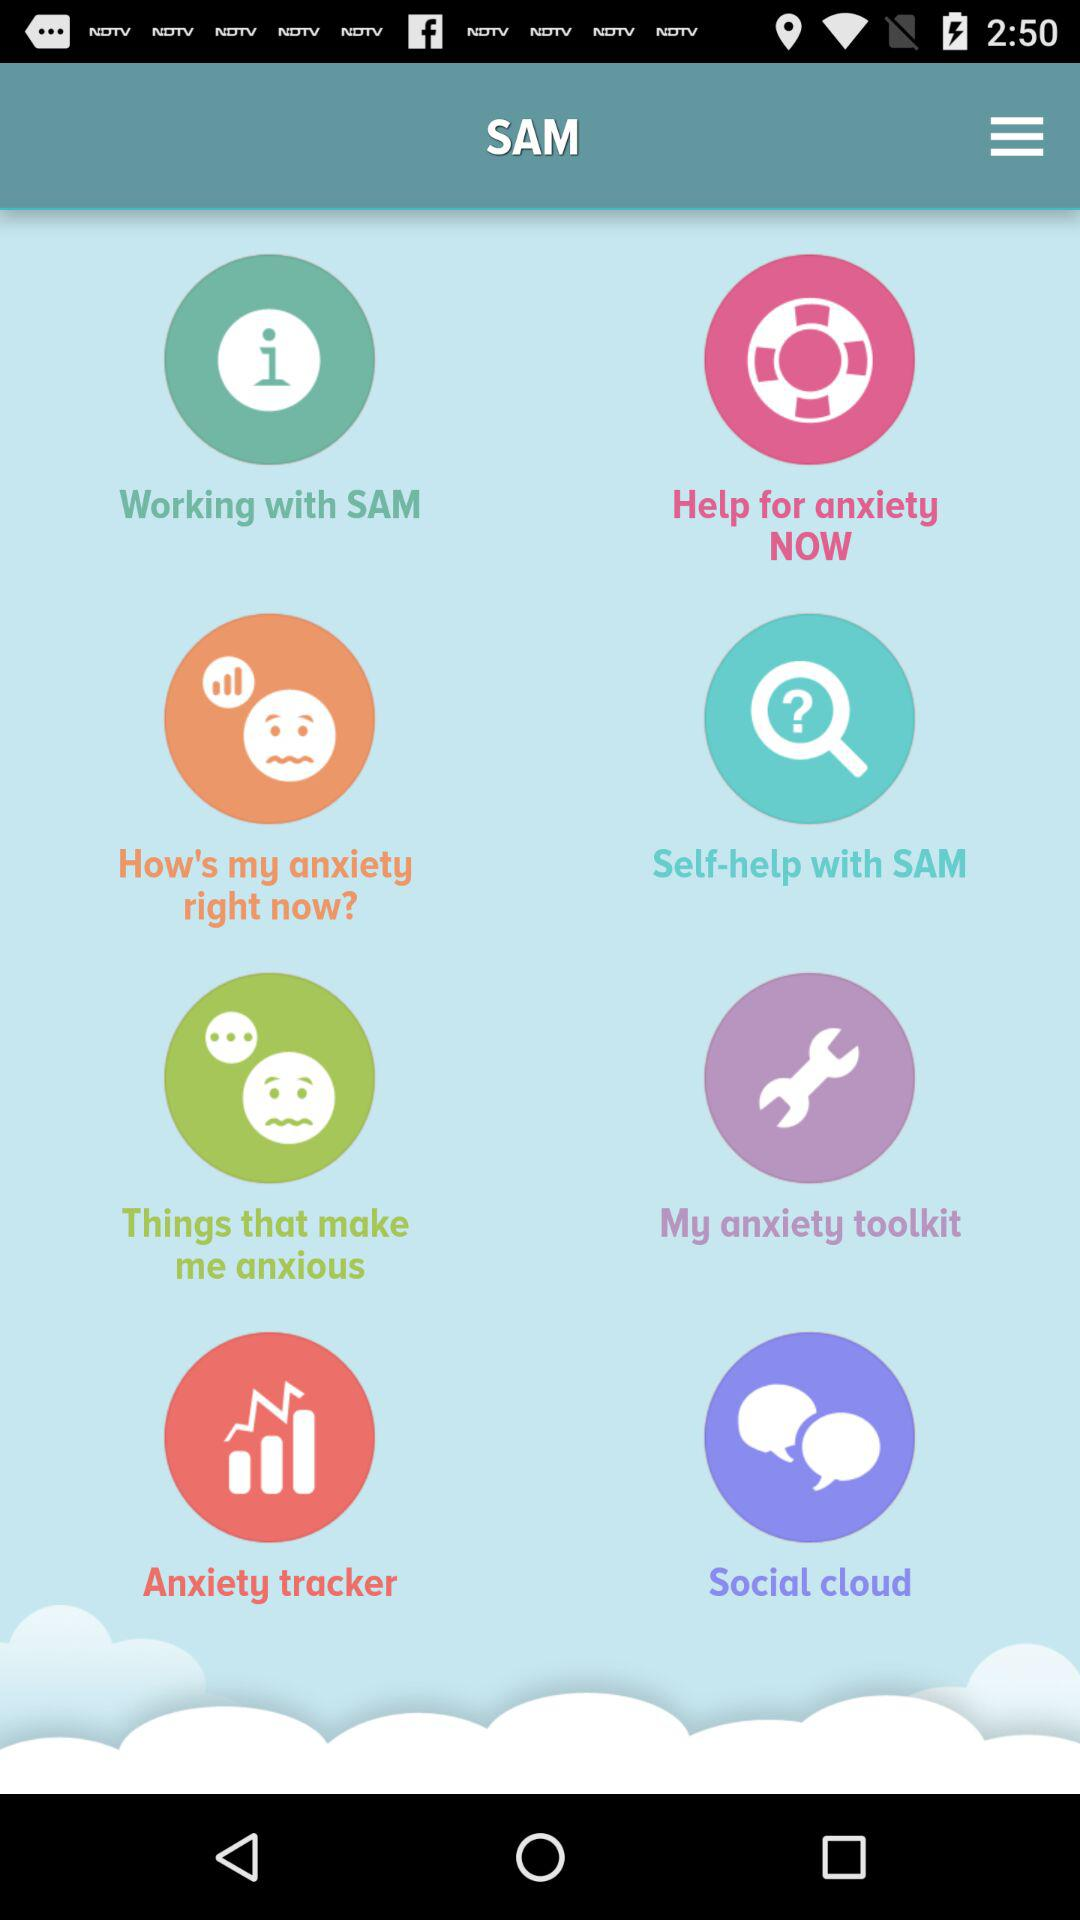What is the user name? The user name is Sam. 